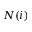Convert formula to latex. <formula><loc_0><loc_0><loc_500><loc_500>N ( i )</formula> 